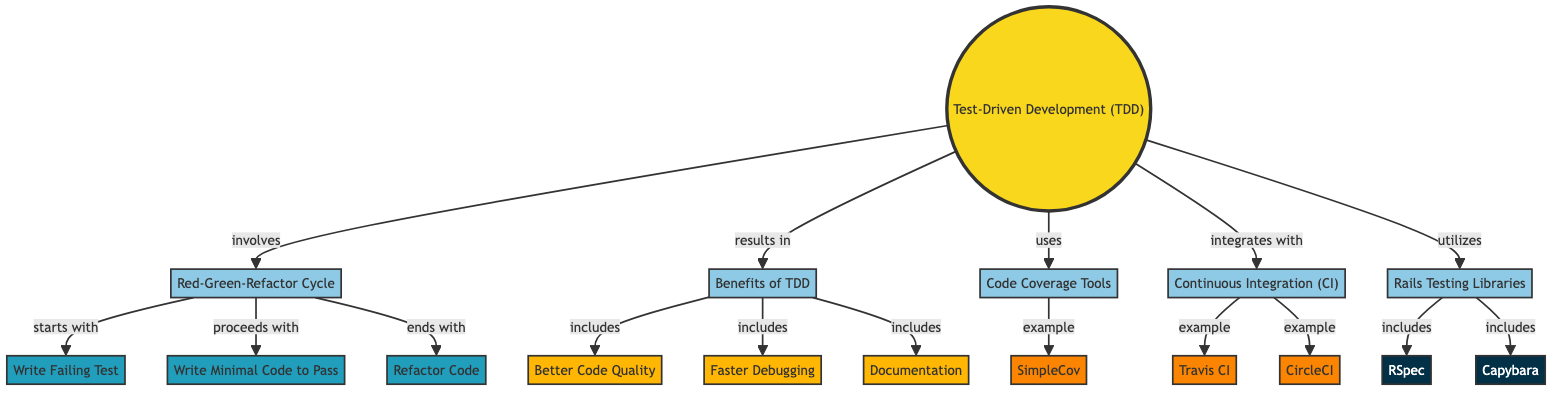What is the main concept of the diagram? The diagram's main concept is "Test-Driven Development (TDD)", indicated by the main node labeled appropriately.
Answer: Test-Driven Development (TDD) How many benefits of TDD are listed in the diagram? The diagram outlines three benefits of TDD, which are represented by the nodes linked to the "Benefits of TDD" concept.
Answer: 3 What is the first action in the Red-Green-Refactor cycle? The first action is "Write Failing Test", which is represented as the node that starts the cycle connected to the "Red-Green-Refactor Cycle".
Answer: Write Failing Test Which tool is an example of Code Coverage Tools? "SimpleCov" is the tool that is specifically mentioned as an example of Code Coverage Tools in the diagram.
Answer: SimpleCov What are the names of the two libraries included in Rails Testing Libraries? The libraries included are "RSpec" and "Capybara", both of which are connected to the "Rails Testing Libraries" node.
Answer: RSpec and Capybara How does TDD relate to Continuous Integration? TDD integrates with Continuous Integration, as shown by the connection between the TDD node and the Continuous Integration node.
Answer: integrates with What is the end action of the Red-Green-Refactor cycle? The end action of the cycle is "Refactor Code", which is the last action connected in the cycle after writing minimal code to pass tests.
Answer: Refactor Code Which CI tool is specifically mentioned in the diagram? "Travis CI" is identified as an example tool under Continuous Integration, indicated by its direct connection to the CI node.
Answer: Travis CI What is one benefit included in the diagram related to TDD? One benefit mentioned is "Better Code Quality", which is linked to the "Benefits of TDD" node.
Answer: Better Code Quality 